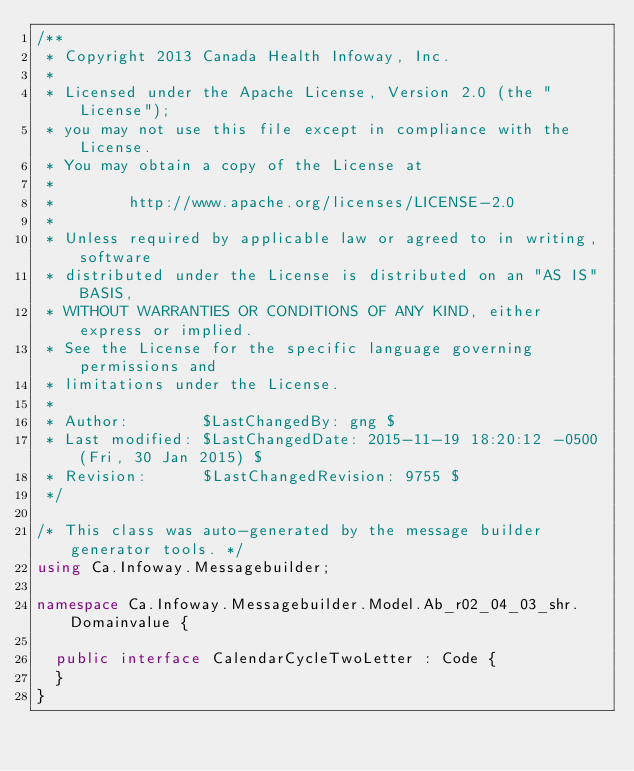<code> <loc_0><loc_0><loc_500><loc_500><_C#_>/**
 * Copyright 2013 Canada Health Infoway, Inc.
 *
 * Licensed under the Apache License, Version 2.0 (the "License");
 * you may not use this file except in compliance with the License.
 * You may obtain a copy of the License at
 *
 *        http://www.apache.org/licenses/LICENSE-2.0
 *
 * Unless required by applicable law or agreed to in writing, software
 * distributed under the License is distributed on an "AS IS" BASIS,
 * WITHOUT WARRANTIES OR CONDITIONS OF ANY KIND, either express or implied.
 * See the License for the specific language governing permissions and
 * limitations under the License.
 *
 * Author:        $LastChangedBy: gng $
 * Last modified: $LastChangedDate: 2015-11-19 18:20:12 -0500 (Fri, 30 Jan 2015) $
 * Revision:      $LastChangedRevision: 9755 $
 */

/* This class was auto-generated by the message builder generator tools. */
using Ca.Infoway.Messagebuilder;

namespace Ca.Infoway.Messagebuilder.Model.Ab_r02_04_03_shr.Domainvalue {

  public interface CalendarCycleTwoLetter : Code {
  }
}
</code> 